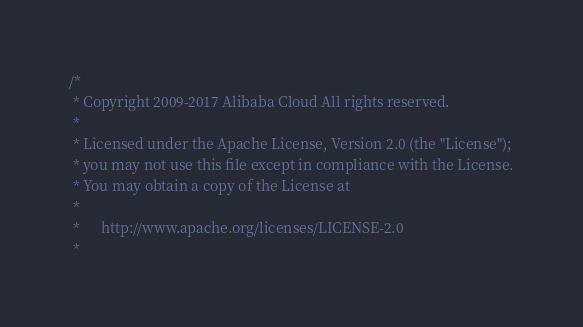<code> <loc_0><loc_0><loc_500><loc_500><_C++_>/*
 * Copyright 2009-2017 Alibaba Cloud All rights reserved.
 * 
 * Licensed under the Apache License, Version 2.0 (the "License");
 * you may not use this file except in compliance with the License.
 * You may obtain a copy of the License at
 * 
 *      http://www.apache.org/licenses/LICENSE-2.0
 * </code> 